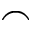<formula> <loc_0><loc_0><loc_500><loc_500>\frown</formula> 